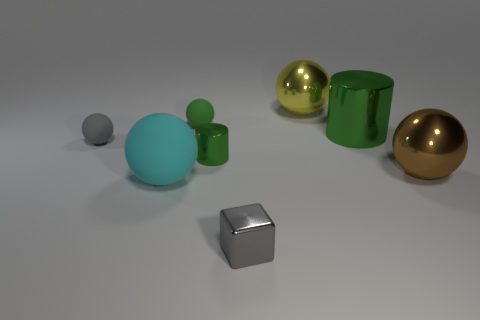Imagine if these objects were part of a game, what could be the goal involving the gold ball? If these objects were part of a game, the goal might involve maneuvering the gold ball to a specific location, perhaps by rolling or using the other objects to guide or carry it there. The game could involve elements of balance, precision, or even a puzzle-solving aspect to determine the correct path. 